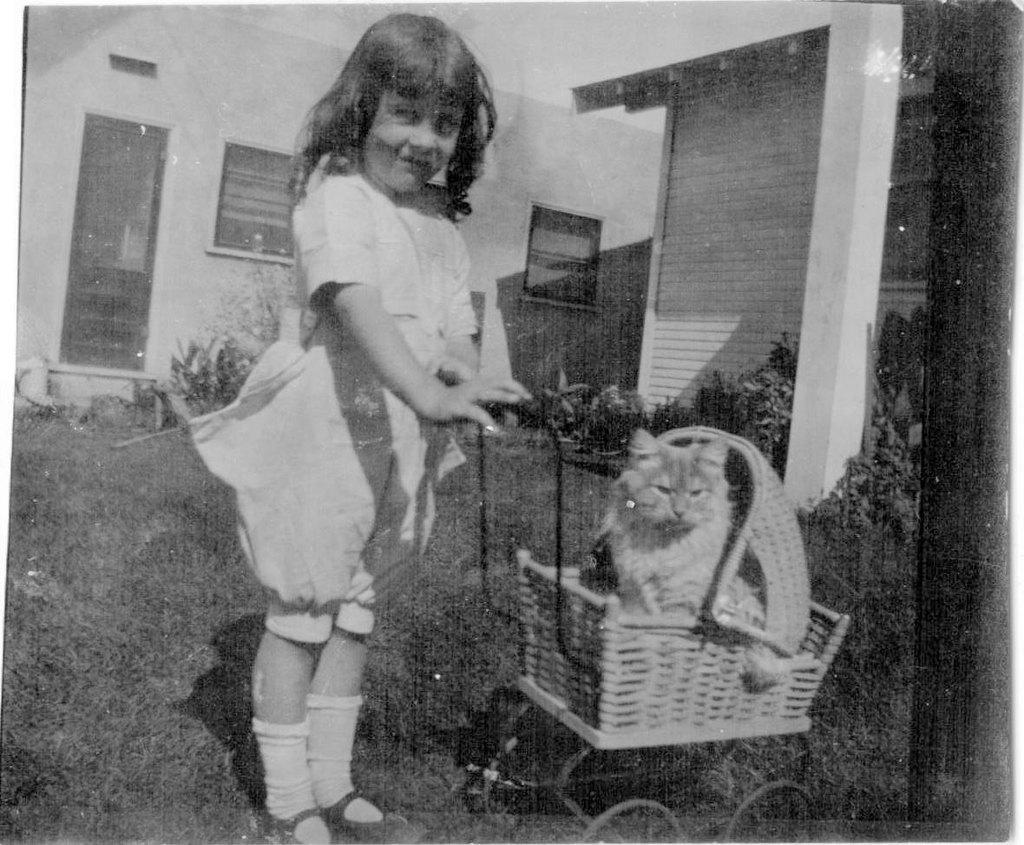Describe this image in one or two sentences. In the center of the image we can see a girl standing and holding a pram in her hand. We can see a cat sitting in the pram. In the background there are seeds and plants. At the bottom there is grass. 